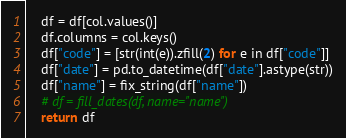<code> <loc_0><loc_0><loc_500><loc_500><_Python_>    df = df[col.values()]
    df.columns = col.keys()
    df["code"] = [str(int(e)).zfill(2) for e in df["code"]]
    df["date"] = pd.to_datetime(df["date"].astype(str))
    df["name"] = fix_string(df["name"])
    # df = fill_dates(df, name="name")
    return df
</code> 